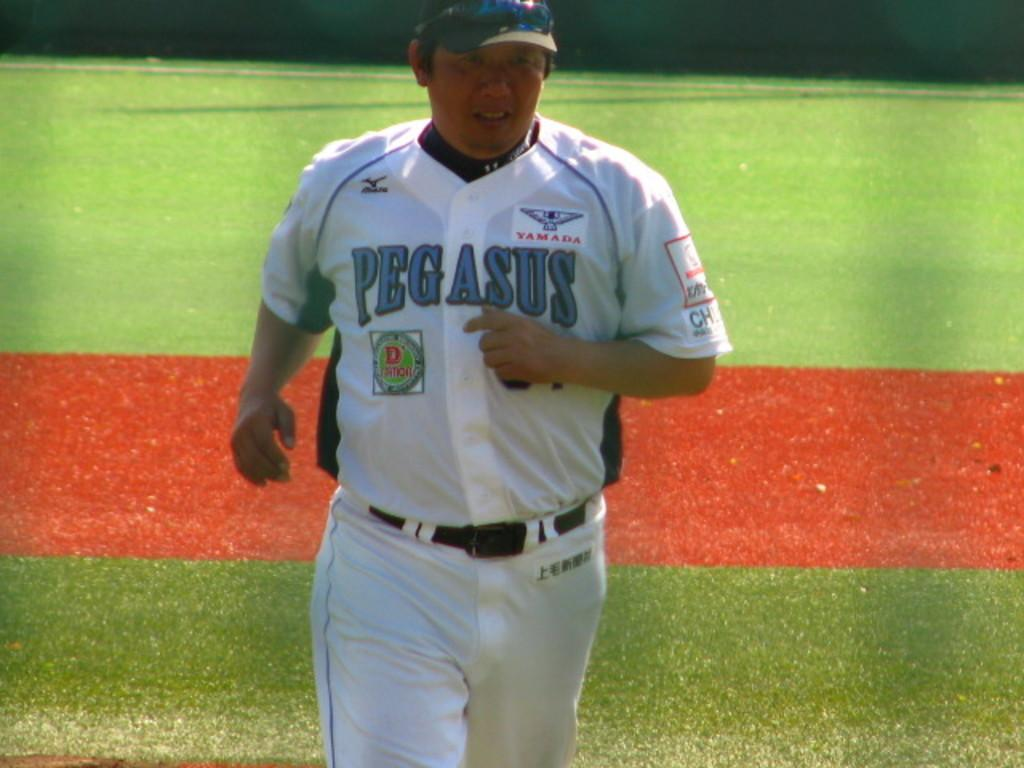<image>
Relay a brief, clear account of the picture shown. A Pegasus team member jogs across the field. 